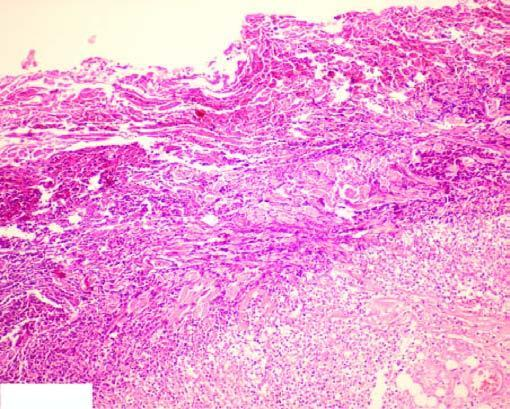re the deposits seen at the periphery?
Answer the question using a single word or phrase. No 